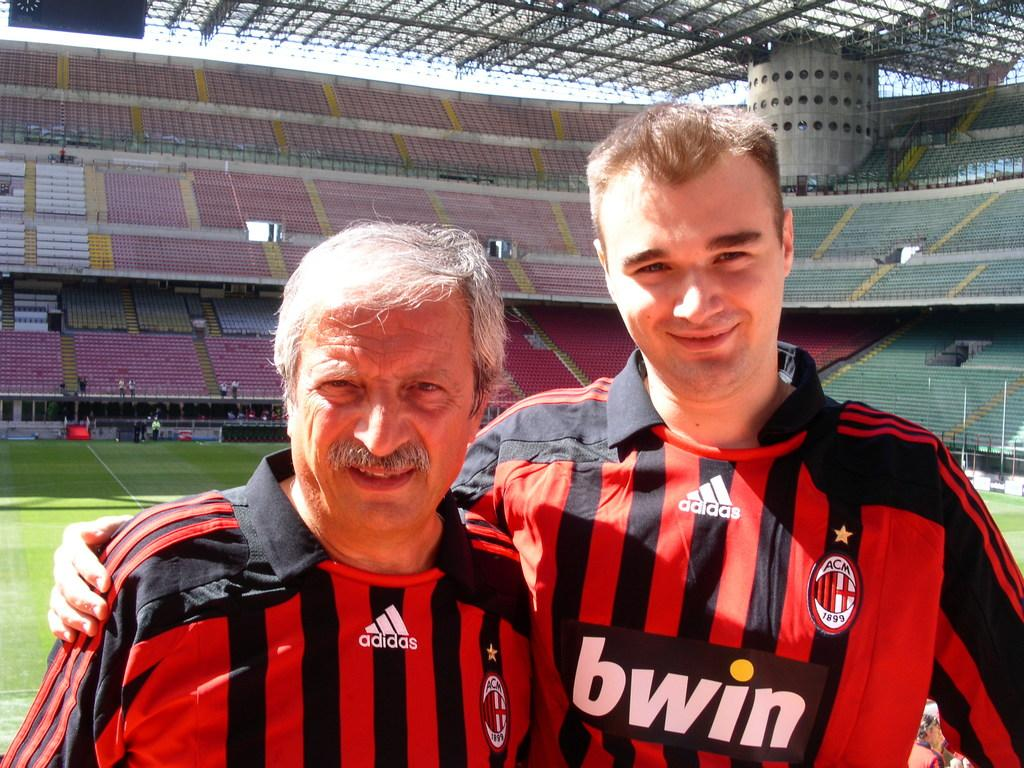<image>
Describe the image concisely. Two members of the bwin team pose next to each other. 